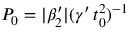<formula> <loc_0><loc_0><loc_500><loc_500>P _ { 0 } = | \beta _ { 2 } ^ { \prime } | ( \gamma ^ { \prime } \, t _ { 0 } ^ { 2 } ) ^ { - 1 }</formula> 